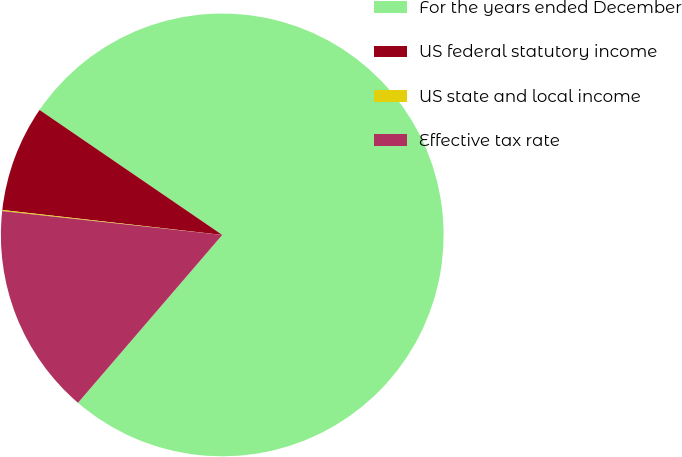<chart> <loc_0><loc_0><loc_500><loc_500><pie_chart><fcel>For the years ended December<fcel>US federal statutory income<fcel>US state and local income<fcel>Effective tax rate<nl><fcel>76.75%<fcel>7.75%<fcel>0.08%<fcel>15.42%<nl></chart> 